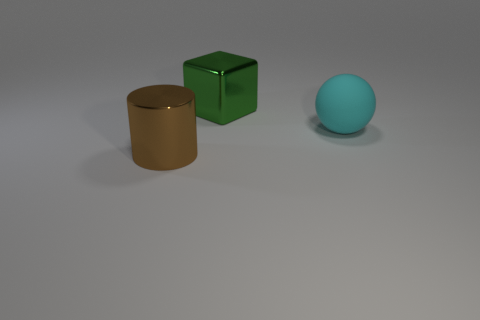Is there a brown cylinder of the same size as the cyan ball?
Your answer should be very brief. Yes. What material is the large thing that is both left of the cyan rubber sphere and behind the cylinder?
Offer a terse response. Metal. How many matte objects are either green things or big cyan spheres?
Provide a succinct answer. 1. The large green thing that is made of the same material as the big cylinder is what shape?
Keep it short and to the point. Cube. How many big metallic objects are both in front of the cyan ball and right of the cylinder?
Ensure brevity in your answer.  0. Are there any other things that are the same shape as the big green thing?
Keep it short and to the point. No. What size is the metallic thing in front of the cyan object?
Ensure brevity in your answer.  Large. How many other objects are the same color as the large sphere?
Make the answer very short. 0. There is a object behind the large object on the right side of the green metallic cube; what is it made of?
Provide a short and direct response. Metal. Is there anything else that is made of the same material as the big cyan thing?
Make the answer very short. No. 